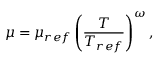Convert formula to latex. <formula><loc_0><loc_0><loc_500><loc_500>\mu = \mu _ { r e f } \left ( \frac { T } { T _ { r e f } } \right ) ^ { \omega } ,</formula> 